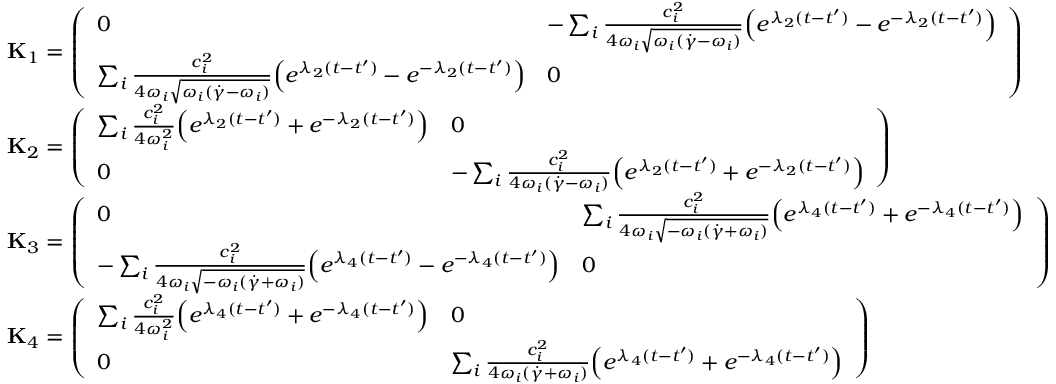Convert formula to latex. <formula><loc_0><loc_0><loc_500><loc_500>\begin{array} { r l } & { { K } _ { 1 } = \left ( \begin{array} { l l } { 0 } & { - \sum _ { i } \frac { c _ { i } ^ { 2 } } { 4 \omega _ { i } \sqrt { \omega _ { i } ( \dot { \gamma } - \omega _ { i } ) } } \left ( e ^ { \lambda _ { 2 } ( t - t ^ { \prime } ) } - e ^ { - \lambda _ { 2 } ( t - t ^ { \prime } ) } \right ) } \\ { \sum _ { i } \frac { c _ { i } ^ { 2 } } { 4 \omega _ { i } \sqrt { \omega _ { i } ( \dot { \gamma } - \omega _ { i } ) } } \left ( e ^ { \lambda _ { 2 } ( t - t ^ { \prime } ) } - e ^ { - \lambda _ { 2 } ( t - t ^ { \prime } ) } \right ) } & { 0 } \end{array} \right ) } \\ & { { K } _ { 2 } = \left ( \begin{array} { l l } { \sum _ { i } \frac { c _ { i } ^ { 2 } } { 4 \omega _ { i } ^ { 2 } } \left ( e ^ { \lambda _ { 2 } ( t - t ^ { \prime } ) } + e ^ { - \lambda _ { 2 } ( t - t ^ { \prime } ) } \right ) } & { 0 } \\ { 0 } & { - \sum _ { i } \frac { c _ { i } ^ { 2 } } { 4 \omega _ { i } ( \dot { \gamma } - \omega _ { i } ) } \left ( e ^ { \lambda _ { 2 } ( t - t ^ { \prime } ) } + e ^ { - \lambda _ { 2 } ( t - t ^ { \prime } ) } \right ) } \end{array} \right ) } \\ & { { K } _ { 3 } = \left ( \begin{array} { l l } { 0 } & { \sum _ { i } \frac { c _ { i } ^ { 2 } } { 4 \omega _ { i } \sqrt { - \omega _ { i } ( \dot { \gamma } + \omega _ { i } ) } } \left ( e ^ { \lambda _ { 4 } ( t - t ^ { \prime } ) } + e ^ { - \lambda _ { 4 } ( t - t ^ { \prime } ) } \right ) } \\ { - \sum _ { i } \frac { c _ { i } ^ { 2 } } { 4 \omega _ { i } \sqrt { - \omega _ { i } ( \dot { \gamma } + \omega _ { i } ) } } \left ( e ^ { \lambda _ { 4 } ( t - t ^ { \prime } ) } - e ^ { - \lambda _ { 4 } ( t - t ^ { \prime } ) } \right ) } & { 0 } \end{array} \right ) } \\ & { { K } _ { 4 } = \left ( \begin{array} { l l } { \sum _ { i } \frac { c _ { i } ^ { 2 } } { 4 \omega _ { i } ^ { 2 } } \left ( e ^ { \lambda _ { 4 } ( t - t ^ { \prime } ) } + e ^ { - \lambda _ { 4 } ( t - t ^ { \prime } ) } \right ) } & { 0 } \\ { 0 } & { \sum _ { i } \frac { c _ { i } ^ { 2 } } { 4 \omega _ { i } ( \dot { \gamma } + \omega _ { i } ) } \left ( e ^ { \lambda _ { 4 } ( t - t ^ { \prime } ) } + e ^ { - \lambda _ { 4 } ( t - t ^ { \prime } ) } \right ) } \end{array} \right ) } \end{array}</formula> 